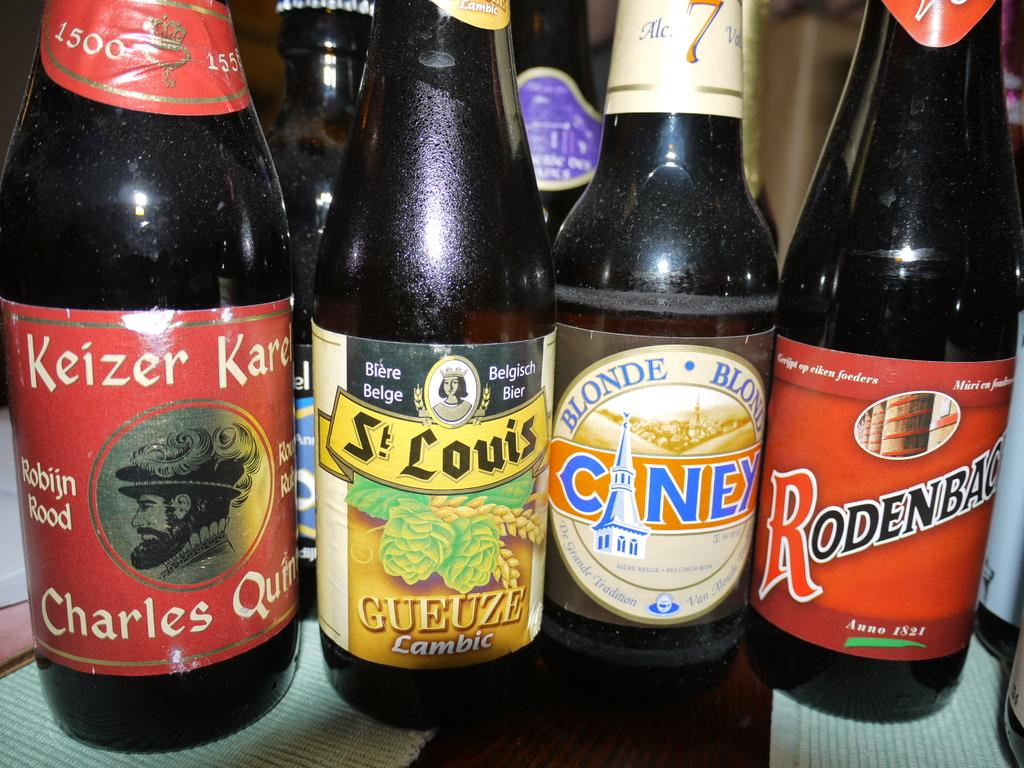Provide a one-sentence caption for the provided image. Four beer bottles with one that is a blonde ale. 